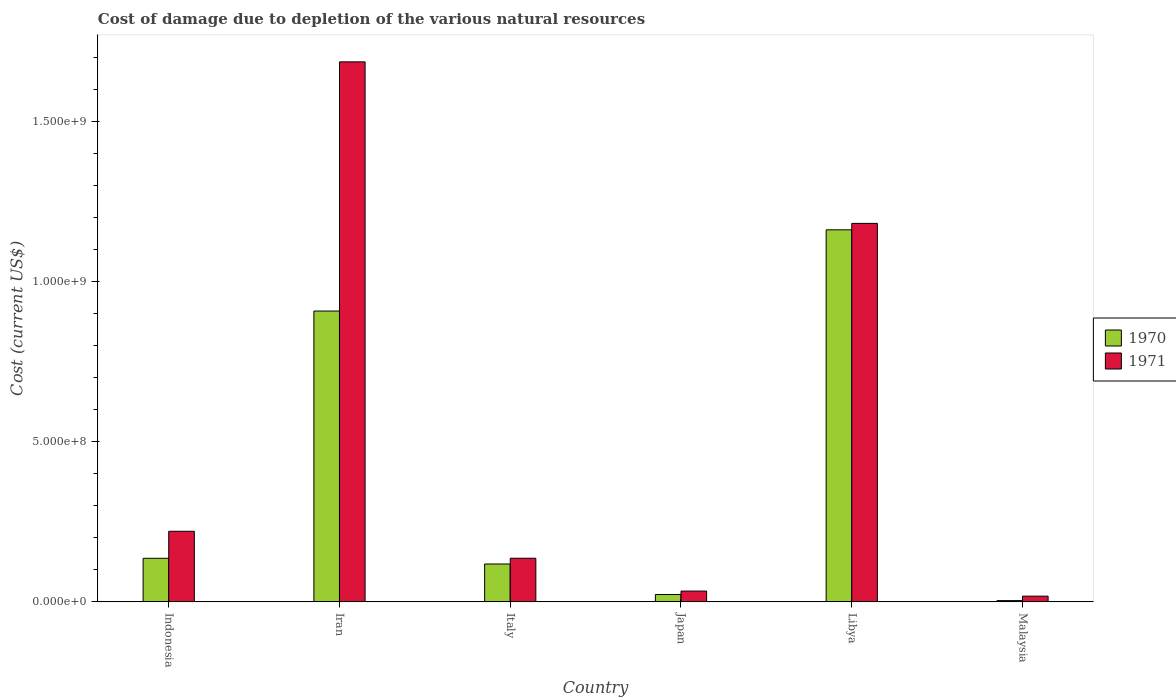How many different coloured bars are there?
Provide a succinct answer. 2. How many groups of bars are there?
Offer a terse response. 6. Are the number of bars per tick equal to the number of legend labels?
Keep it short and to the point. Yes. Are the number of bars on each tick of the X-axis equal?
Give a very brief answer. Yes. In how many cases, is the number of bars for a given country not equal to the number of legend labels?
Your answer should be compact. 0. What is the cost of damage caused due to the depletion of various natural resources in 1970 in Libya?
Offer a very short reply. 1.16e+09. Across all countries, what is the maximum cost of damage caused due to the depletion of various natural resources in 1971?
Your answer should be very brief. 1.69e+09. Across all countries, what is the minimum cost of damage caused due to the depletion of various natural resources in 1971?
Your answer should be very brief. 1.79e+07. In which country was the cost of damage caused due to the depletion of various natural resources in 1971 maximum?
Provide a succinct answer. Iran. In which country was the cost of damage caused due to the depletion of various natural resources in 1971 minimum?
Offer a terse response. Malaysia. What is the total cost of damage caused due to the depletion of various natural resources in 1970 in the graph?
Make the answer very short. 2.35e+09. What is the difference between the cost of damage caused due to the depletion of various natural resources in 1970 in Italy and that in Libya?
Make the answer very short. -1.04e+09. What is the difference between the cost of damage caused due to the depletion of various natural resources in 1970 in Iran and the cost of damage caused due to the depletion of various natural resources in 1971 in Malaysia?
Your answer should be very brief. 8.90e+08. What is the average cost of damage caused due to the depletion of various natural resources in 1970 per country?
Give a very brief answer. 3.92e+08. What is the difference between the cost of damage caused due to the depletion of various natural resources of/in 1970 and cost of damage caused due to the depletion of various natural resources of/in 1971 in Malaysia?
Your answer should be very brief. -1.39e+07. In how many countries, is the cost of damage caused due to the depletion of various natural resources in 1971 greater than 1400000000 US$?
Keep it short and to the point. 1. What is the ratio of the cost of damage caused due to the depletion of various natural resources in 1970 in Iran to that in Libya?
Offer a very short reply. 0.78. What is the difference between the highest and the second highest cost of damage caused due to the depletion of various natural resources in 1970?
Provide a succinct answer. -7.72e+08. What is the difference between the highest and the lowest cost of damage caused due to the depletion of various natural resources in 1970?
Offer a very short reply. 1.16e+09. In how many countries, is the cost of damage caused due to the depletion of various natural resources in 1970 greater than the average cost of damage caused due to the depletion of various natural resources in 1970 taken over all countries?
Give a very brief answer. 2. Is the sum of the cost of damage caused due to the depletion of various natural resources in 1971 in Italy and Libya greater than the maximum cost of damage caused due to the depletion of various natural resources in 1970 across all countries?
Your answer should be very brief. Yes. What does the 2nd bar from the left in Italy represents?
Your answer should be very brief. 1971. How many bars are there?
Make the answer very short. 12. Are the values on the major ticks of Y-axis written in scientific E-notation?
Offer a terse response. Yes. How many legend labels are there?
Make the answer very short. 2. How are the legend labels stacked?
Provide a short and direct response. Vertical. What is the title of the graph?
Keep it short and to the point. Cost of damage due to depletion of the various natural resources. Does "1962" appear as one of the legend labels in the graph?
Provide a succinct answer. No. What is the label or title of the X-axis?
Your answer should be compact. Country. What is the label or title of the Y-axis?
Ensure brevity in your answer.  Cost (current US$). What is the Cost (current US$) of 1970 in Indonesia?
Give a very brief answer. 1.36e+08. What is the Cost (current US$) in 1971 in Indonesia?
Make the answer very short. 2.20e+08. What is the Cost (current US$) of 1970 in Iran?
Provide a short and direct response. 9.08e+08. What is the Cost (current US$) of 1971 in Iran?
Provide a succinct answer. 1.69e+09. What is the Cost (current US$) in 1970 in Italy?
Your response must be concise. 1.18e+08. What is the Cost (current US$) in 1971 in Italy?
Offer a very short reply. 1.36e+08. What is the Cost (current US$) of 1970 in Japan?
Offer a very short reply. 2.30e+07. What is the Cost (current US$) in 1971 in Japan?
Offer a terse response. 3.37e+07. What is the Cost (current US$) in 1970 in Libya?
Your answer should be very brief. 1.16e+09. What is the Cost (current US$) of 1971 in Libya?
Offer a terse response. 1.18e+09. What is the Cost (current US$) in 1970 in Malaysia?
Your answer should be very brief. 3.97e+06. What is the Cost (current US$) of 1971 in Malaysia?
Provide a short and direct response. 1.79e+07. Across all countries, what is the maximum Cost (current US$) of 1970?
Keep it short and to the point. 1.16e+09. Across all countries, what is the maximum Cost (current US$) of 1971?
Offer a terse response. 1.69e+09. Across all countries, what is the minimum Cost (current US$) of 1970?
Provide a succinct answer. 3.97e+06. Across all countries, what is the minimum Cost (current US$) of 1971?
Your answer should be compact. 1.79e+07. What is the total Cost (current US$) in 1970 in the graph?
Give a very brief answer. 2.35e+09. What is the total Cost (current US$) in 1971 in the graph?
Ensure brevity in your answer.  3.27e+09. What is the difference between the Cost (current US$) of 1970 in Indonesia and that in Iran?
Offer a terse response. -7.72e+08. What is the difference between the Cost (current US$) of 1971 in Indonesia and that in Iran?
Offer a very short reply. -1.46e+09. What is the difference between the Cost (current US$) of 1970 in Indonesia and that in Italy?
Keep it short and to the point. 1.78e+07. What is the difference between the Cost (current US$) of 1971 in Indonesia and that in Italy?
Your response must be concise. 8.41e+07. What is the difference between the Cost (current US$) of 1970 in Indonesia and that in Japan?
Offer a very short reply. 1.13e+08. What is the difference between the Cost (current US$) in 1971 in Indonesia and that in Japan?
Make the answer very short. 1.87e+08. What is the difference between the Cost (current US$) in 1970 in Indonesia and that in Libya?
Provide a short and direct response. -1.03e+09. What is the difference between the Cost (current US$) in 1971 in Indonesia and that in Libya?
Offer a very short reply. -9.61e+08. What is the difference between the Cost (current US$) in 1970 in Indonesia and that in Malaysia?
Make the answer very short. 1.32e+08. What is the difference between the Cost (current US$) of 1971 in Indonesia and that in Malaysia?
Your answer should be very brief. 2.02e+08. What is the difference between the Cost (current US$) of 1970 in Iran and that in Italy?
Make the answer very short. 7.89e+08. What is the difference between the Cost (current US$) in 1971 in Iran and that in Italy?
Your answer should be compact. 1.55e+09. What is the difference between the Cost (current US$) of 1970 in Iran and that in Japan?
Ensure brevity in your answer.  8.85e+08. What is the difference between the Cost (current US$) of 1971 in Iran and that in Japan?
Ensure brevity in your answer.  1.65e+09. What is the difference between the Cost (current US$) in 1970 in Iran and that in Libya?
Provide a short and direct response. -2.53e+08. What is the difference between the Cost (current US$) of 1971 in Iran and that in Libya?
Give a very brief answer. 5.04e+08. What is the difference between the Cost (current US$) of 1970 in Iran and that in Malaysia?
Offer a very short reply. 9.04e+08. What is the difference between the Cost (current US$) in 1971 in Iran and that in Malaysia?
Your answer should be compact. 1.67e+09. What is the difference between the Cost (current US$) in 1970 in Italy and that in Japan?
Provide a short and direct response. 9.52e+07. What is the difference between the Cost (current US$) of 1971 in Italy and that in Japan?
Your answer should be very brief. 1.02e+08. What is the difference between the Cost (current US$) in 1970 in Italy and that in Libya?
Ensure brevity in your answer.  -1.04e+09. What is the difference between the Cost (current US$) of 1971 in Italy and that in Libya?
Make the answer very short. -1.05e+09. What is the difference between the Cost (current US$) of 1970 in Italy and that in Malaysia?
Your response must be concise. 1.14e+08. What is the difference between the Cost (current US$) of 1971 in Italy and that in Malaysia?
Offer a very short reply. 1.18e+08. What is the difference between the Cost (current US$) in 1970 in Japan and that in Libya?
Offer a very short reply. -1.14e+09. What is the difference between the Cost (current US$) of 1971 in Japan and that in Libya?
Ensure brevity in your answer.  -1.15e+09. What is the difference between the Cost (current US$) in 1970 in Japan and that in Malaysia?
Provide a short and direct response. 1.90e+07. What is the difference between the Cost (current US$) in 1971 in Japan and that in Malaysia?
Provide a short and direct response. 1.58e+07. What is the difference between the Cost (current US$) of 1970 in Libya and that in Malaysia?
Offer a very short reply. 1.16e+09. What is the difference between the Cost (current US$) of 1971 in Libya and that in Malaysia?
Give a very brief answer. 1.16e+09. What is the difference between the Cost (current US$) in 1970 in Indonesia and the Cost (current US$) in 1971 in Iran?
Provide a succinct answer. -1.55e+09. What is the difference between the Cost (current US$) in 1970 in Indonesia and the Cost (current US$) in 1971 in Italy?
Make the answer very short. -1.72e+05. What is the difference between the Cost (current US$) in 1970 in Indonesia and the Cost (current US$) in 1971 in Japan?
Keep it short and to the point. 1.02e+08. What is the difference between the Cost (current US$) in 1970 in Indonesia and the Cost (current US$) in 1971 in Libya?
Your answer should be very brief. -1.05e+09. What is the difference between the Cost (current US$) of 1970 in Indonesia and the Cost (current US$) of 1971 in Malaysia?
Give a very brief answer. 1.18e+08. What is the difference between the Cost (current US$) of 1970 in Iran and the Cost (current US$) of 1971 in Italy?
Provide a short and direct response. 7.71e+08. What is the difference between the Cost (current US$) in 1970 in Iran and the Cost (current US$) in 1971 in Japan?
Ensure brevity in your answer.  8.74e+08. What is the difference between the Cost (current US$) in 1970 in Iran and the Cost (current US$) in 1971 in Libya?
Ensure brevity in your answer.  -2.74e+08. What is the difference between the Cost (current US$) in 1970 in Iran and the Cost (current US$) in 1971 in Malaysia?
Your answer should be very brief. 8.90e+08. What is the difference between the Cost (current US$) in 1970 in Italy and the Cost (current US$) in 1971 in Japan?
Your answer should be very brief. 8.45e+07. What is the difference between the Cost (current US$) of 1970 in Italy and the Cost (current US$) of 1971 in Libya?
Ensure brevity in your answer.  -1.06e+09. What is the difference between the Cost (current US$) in 1970 in Italy and the Cost (current US$) in 1971 in Malaysia?
Your answer should be very brief. 1.00e+08. What is the difference between the Cost (current US$) in 1970 in Japan and the Cost (current US$) in 1971 in Libya?
Provide a succinct answer. -1.16e+09. What is the difference between the Cost (current US$) of 1970 in Japan and the Cost (current US$) of 1971 in Malaysia?
Offer a very short reply. 5.12e+06. What is the difference between the Cost (current US$) of 1970 in Libya and the Cost (current US$) of 1971 in Malaysia?
Your answer should be very brief. 1.14e+09. What is the average Cost (current US$) of 1970 per country?
Offer a very short reply. 3.92e+08. What is the average Cost (current US$) in 1971 per country?
Your answer should be very brief. 5.46e+08. What is the difference between the Cost (current US$) of 1970 and Cost (current US$) of 1971 in Indonesia?
Offer a very short reply. -8.43e+07. What is the difference between the Cost (current US$) in 1970 and Cost (current US$) in 1971 in Iran?
Offer a very short reply. -7.78e+08. What is the difference between the Cost (current US$) of 1970 and Cost (current US$) of 1971 in Italy?
Give a very brief answer. -1.80e+07. What is the difference between the Cost (current US$) in 1970 and Cost (current US$) in 1971 in Japan?
Your response must be concise. -1.07e+07. What is the difference between the Cost (current US$) of 1970 and Cost (current US$) of 1971 in Libya?
Your response must be concise. -2.01e+07. What is the difference between the Cost (current US$) of 1970 and Cost (current US$) of 1971 in Malaysia?
Make the answer very short. -1.39e+07. What is the ratio of the Cost (current US$) of 1970 in Indonesia to that in Iran?
Your response must be concise. 0.15. What is the ratio of the Cost (current US$) of 1971 in Indonesia to that in Iran?
Give a very brief answer. 0.13. What is the ratio of the Cost (current US$) in 1970 in Indonesia to that in Italy?
Give a very brief answer. 1.15. What is the ratio of the Cost (current US$) of 1971 in Indonesia to that in Italy?
Your response must be concise. 1.62. What is the ratio of the Cost (current US$) in 1970 in Indonesia to that in Japan?
Your answer should be very brief. 5.91. What is the ratio of the Cost (current US$) in 1971 in Indonesia to that in Japan?
Make the answer very short. 6.54. What is the ratio of the Cost (current US$) in 1970 in Indonesia to that in Libya?
Your answer should be compact. 0.12. What is the ratio of the Cost (current US$) in 1971 in Indonesia to that in Libya?
Offer a very short reply. 0.19. What is the ratio of the Cost (current US$) in 1970 in Indonesia to that in Malaysia?
Ensure brevity in your answer.  34.26. What is the ratio of the Cost (current US$) in 1971 in Indonesia to that in Malaysia?
Provide a succinct answer. 12.32. What is the ratio of the Cost (current US$) in 1970 in Iran to that in Italy?
Offer a terse response. 7.68. What is the ratio of the Cost (current US$) of 1971 in Iran to that in Italy?
Make the answer very short. 12.37. What is the ratio of the Cost (current US$) of 1970 in Iran to that in Japan?
Ensure brevity in your answer.  39.46. What is the ratio of the Cost (current US$) of 1971 in Iran to that in Japan?
Offer a terse response. 50. What is the ratio of the Cost (current US$) in 1970 in Iran to that in Libya?
Offer a very short reply. 0.78. What is the ratio of the Cost (current US$) in 1971 in Iran to that in Libya?
Provide a short and direct response. 1.43. What is the ratio of the Cost (current US$) in 1970 in Iran to that in Malaysia?
Provide a succinct answer. 228.6. What is the ratio of the Cost (current US$) in 1971 in Iran to that in Malaysia?
Provide a short and direct response. 94.25. What is the ratio of the Cost (current US$) in 1970 in Italy to that in Japan?
Offer a terse response. 5.14. What is the ratio of the Cost (current US$) in 1971 in Italy to that in Japan?
Give a very brief answer. 4.04. What is the ratio of the Cost (current US$) of 1970 in Italy to that in Libya?
Give a very brief answer. 0.1. What is the ratio of the Cost (current US$) in 1971 in Italy to that in Libya?
Provide a succinct answer. 0.12. What is the ratio of the Cost (current US$) in 1970 in Italy to that in Malaysia?
Offer a terse response. 29.77. What is the ratio of the Cost (current US$) in 1971 in Italy to that in Malaysia?
Give a very brief answer. 7.62. What is the ratio of the Cost (current US$) in 1970 in Japan to that in Libya?
Provide a short and direct response. 0.02. What is the ratio of the Cost (current US$) in 1971 in Japan to that in Libya?
Provide a succinct answer. 0.03. What is the ratio of the Cost (current US$) in 1970 in Japan to that in Malaysia?
Make the answer very short. 5.79. What is the ratio of the Cost (current US$) in 1971 in Japan to that in Malaysia?
Your answer should be very brief. 1.88. What is the ratio of the Cost (current US$) of 1970 in Libya to that in Malaysia?
Provide a succinct answer. 292.43. What is the ratio of the Cost (current US$) in 1971 in Libya to that in Malaysia?
Make the answer very short. 66.06. What is the difference between the highest and the second highest Cost (current US$) in 1970?
Provide a short and direct response. 2.53e+08. What is the difference between the highest and the second highest Cost (current US$) of 1971?
Offer a terse response. 5.04e+08. What is the difference between the highest and the lowest Cost (current US$) of 1970?
Make the answer very short. 1.16e+09. What is the difference between the highest and the lowest Cost (current US$) of 1971?
Give a very brief answer. 1.67e+09. 